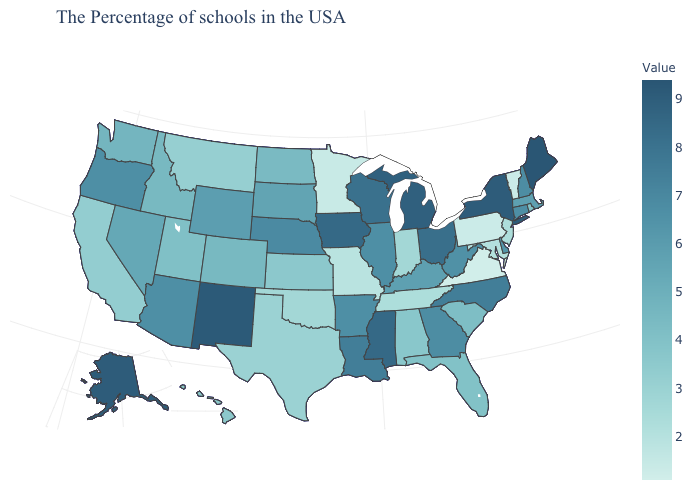Does the map have missing data?
Short answer required. No. Which states have the highest value in the USA?
Give a very brief answer. Maine. Does the map have missing data?
Keep it brief. No. Among the states that border Tennessee , does Kentucky have the highest value?
Write a very short answer. No. Is the legend a continuous bar?
Quick response, please. Yes. Among the states that border Arkansas , which have the highest value?
Answer briefly. Mississippi. Which states have the lowest value in the USA?
Quick response, please. Virginia. 